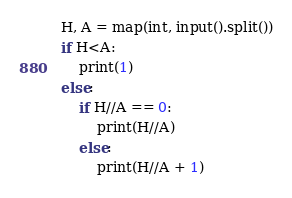<code> <loc_0><loc_0><loc_500><loc_500><_Python_>H, A = map(int, input().split())
if H<A:
    print(1)
else:
    if H//A == 0:
        print(H//A)
    else:
        print(H//A + 1)</code> 